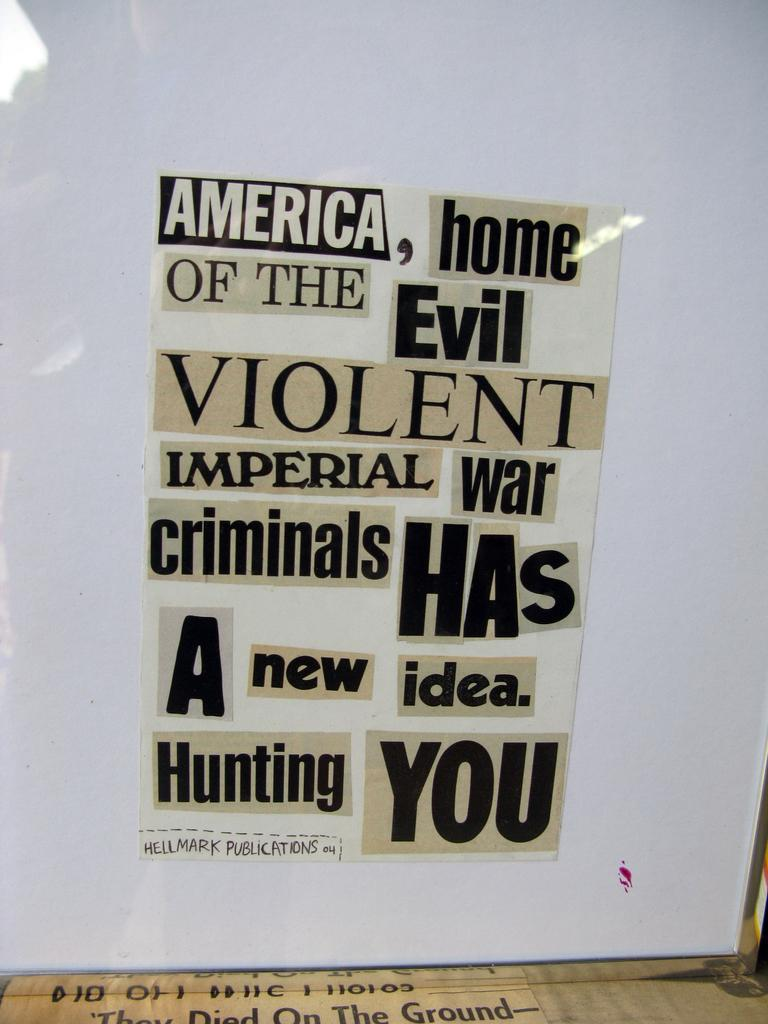Provide a one-sentence caption for the provided image. A paper with cut out words the last two of which are Hunting you. 